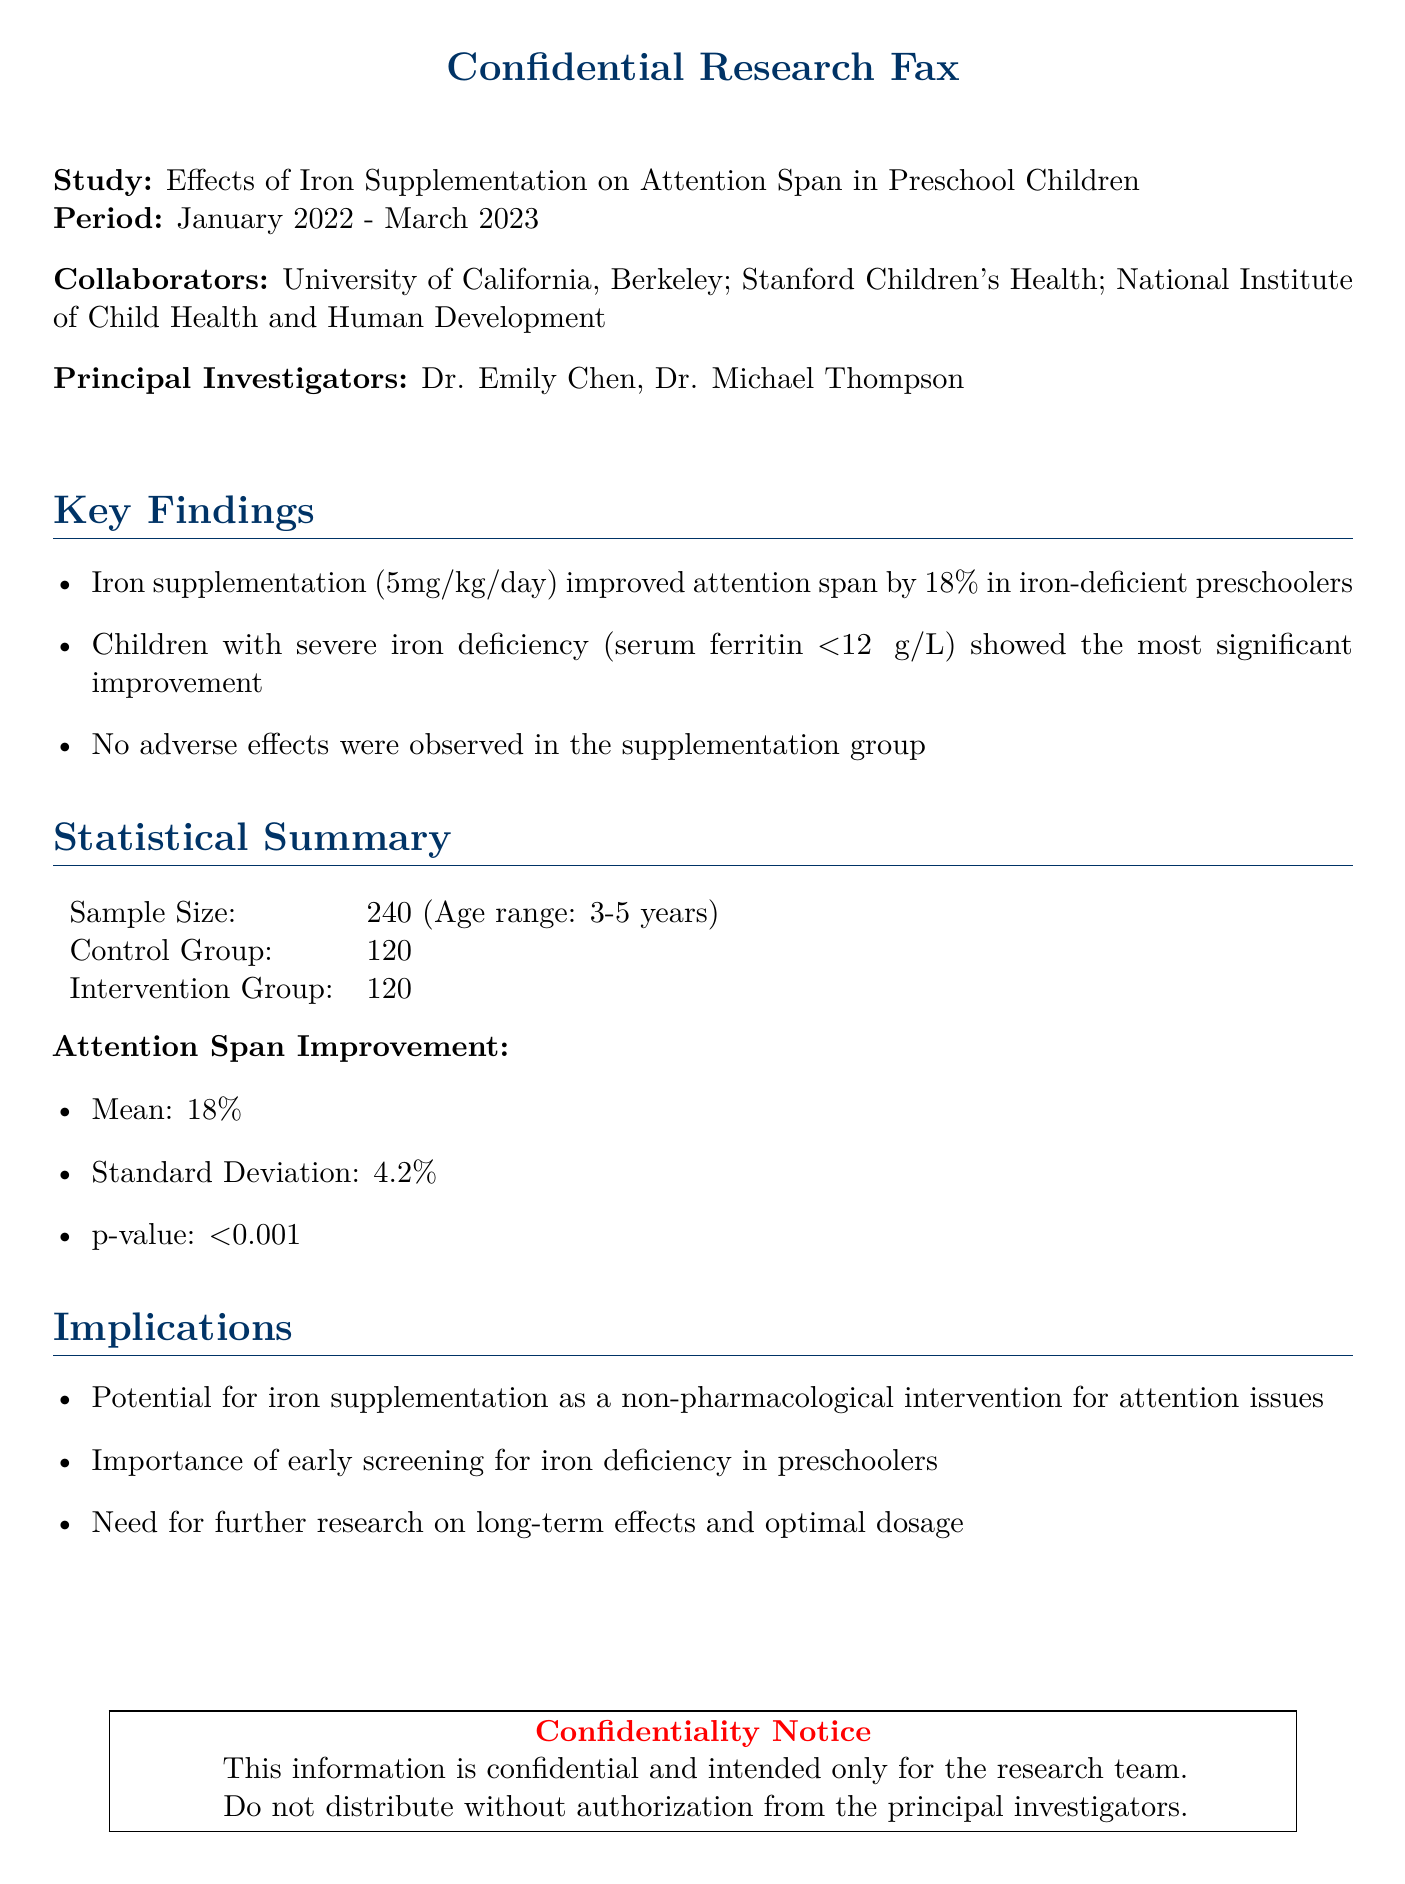what is the study title? The title of the study is mentioned at the beginning of the document, which is "Effects of Iron Supplementation on Attention Span in Preschool Children."
Answer: Effects of Iron Supplementation on Attention Span in Preschool Children who are the principal investigators? The principal investigators are listed in the document as Dr. Emily Chen and Dr. Michael Thompson.
Answer: Dr. Emily Chen, Dr. Michael Thompson what is the sample size of the study? The sample size is specified in the statistical summary section as 240.
Answer: 240 what is the improvement in attention span? The improvement in attention span is highlighted under key findings as 18%.
Answer: 18% what p-value indicates significance in this study? The p-value associated with attention span improvement is stated in the statistical summary, which is less than 0.001.
Answer: <0.001 which group showed the most significant improvement? The findings indicate that children with severe iron deficiency showed the most significant improvement in attention span.
Answer: severe iron deficiency what is the duration of the study? The document specifies the period of the study as January 2022 - March 2023.
Answer: January 2022 - March 2023 what recommendation is made regarding iron deficiency? The implications section of the document mentions the importance of early screening for iron deficiency in preschoolers.
Answer: early screening for iron deficiency were any adverse effects reported? The key findings state that no adverse effects were observed in the supplementation group.
Answer: no adverse effects 